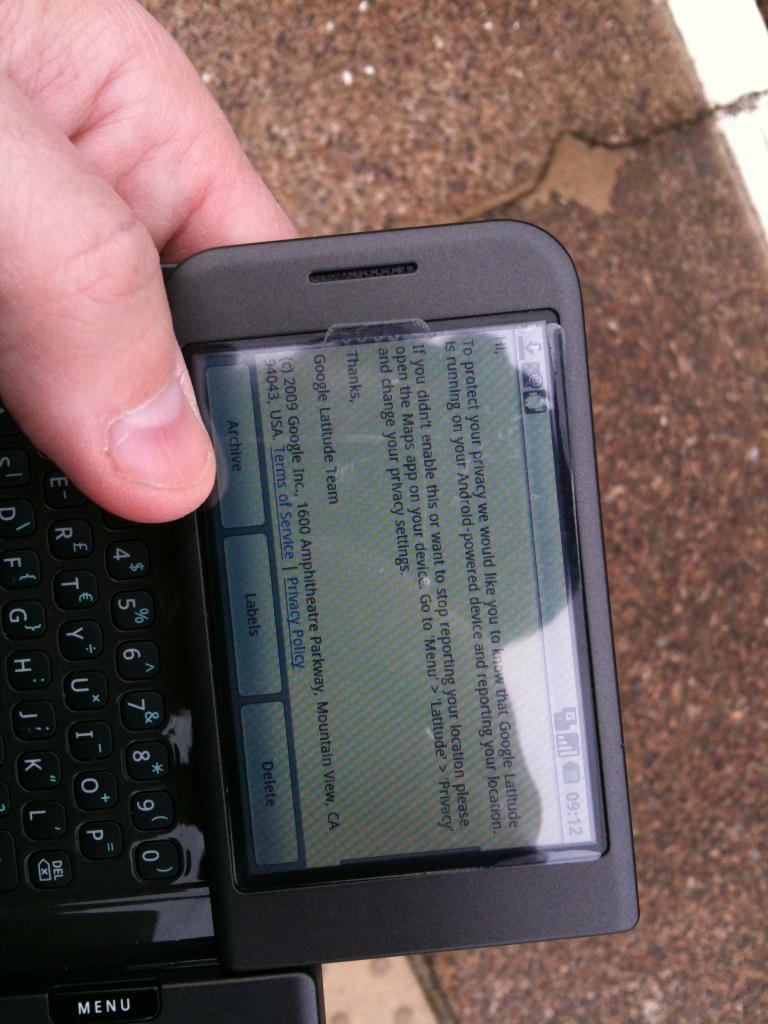<image>
Describe the image concisely. A handheld device displaying privacy information from Google 